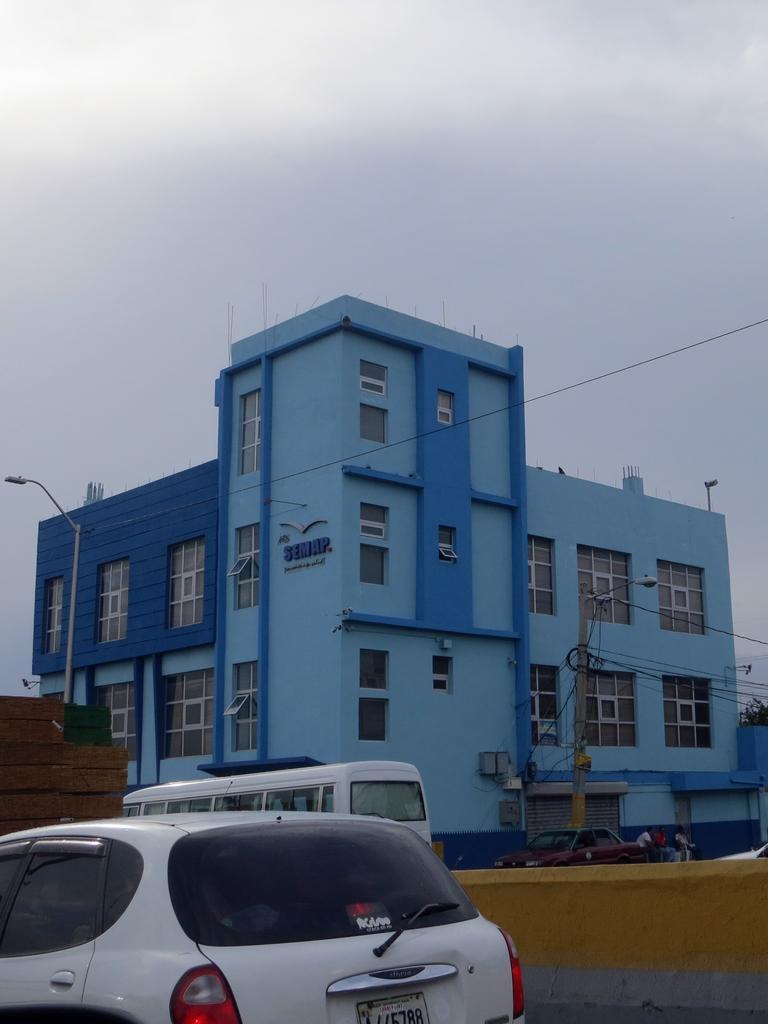Can you describe this image briefly? In the center of the image there is a building. At the bottom we can see cars and a bus. There are poles. At the top there is sky. 